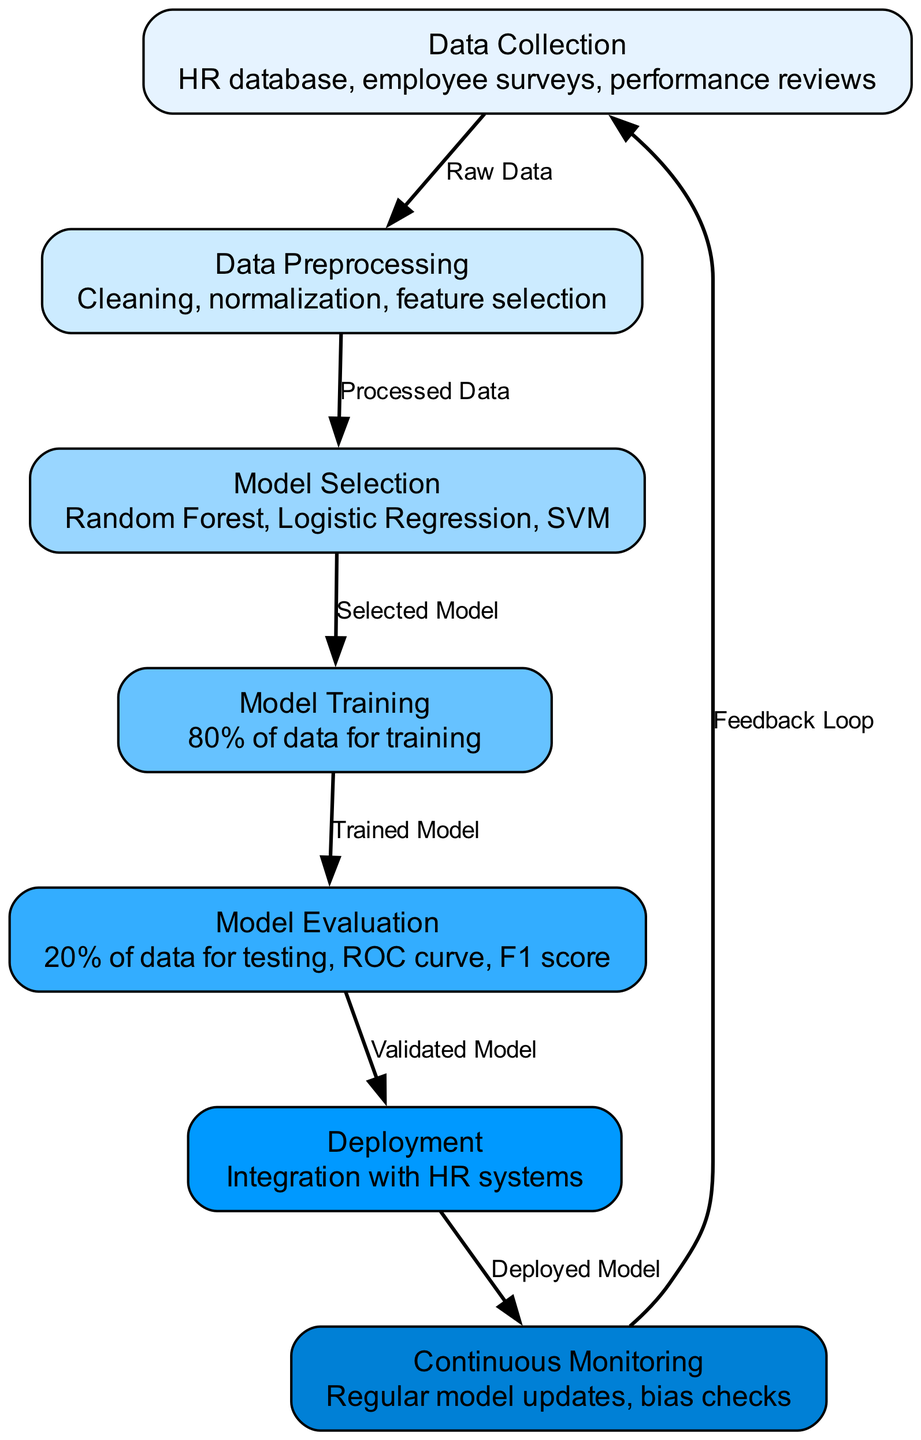What is the first stage in the machine learning process? The diagram lists "Data Collection" as the first node, indicating it is the first stage in the process of predicting employee retention.
Answer: Data Collection How many models are suggested for selection in the model selection stage? The diagram mentions three models: "Random Forest," "Logistic Regression," and "SVM," showing that there are three options available for selection.
Answer: Three What does the deployment stage integrate with? According to the details in the diagram, "Deployment" integrates with "HR systems," indicating the systems that will use the model after its deployment.
Answer: HR systems What percentage of data is used for training the model? The "Model Training" node states that "80% of data" is allocated for training purposes, indicating the portion of data used during this phase.
Answer: 80% What comes after model evaluation in the process? The diagram shows the flow from "Model Evaluation" to "Deployment," indicating that deployment is the next step after evaluating the model.
Answer: Deployment Which node follows the continuous monitoring stage? The diagram indicates a feedback loop from "Continuous Monitoring" back to "Data Collection," meaning Data Collection follows Continuous Monitoring.
Answer: Data Collection What type of checks are mentioned in the continuous monitoring stage? The details in the "Continuous Monitoring" node specify "bias checks," indicating these checks are part of the ongoing monitoring process.
Answer: Bias checks What type of data is processed in the data preprocessing step? The arrow from "Data Collection" to "Data Preprocessing" is labeled "Raw Data," showing that raw data is the type of data being processed.
Answer: Raw Data 